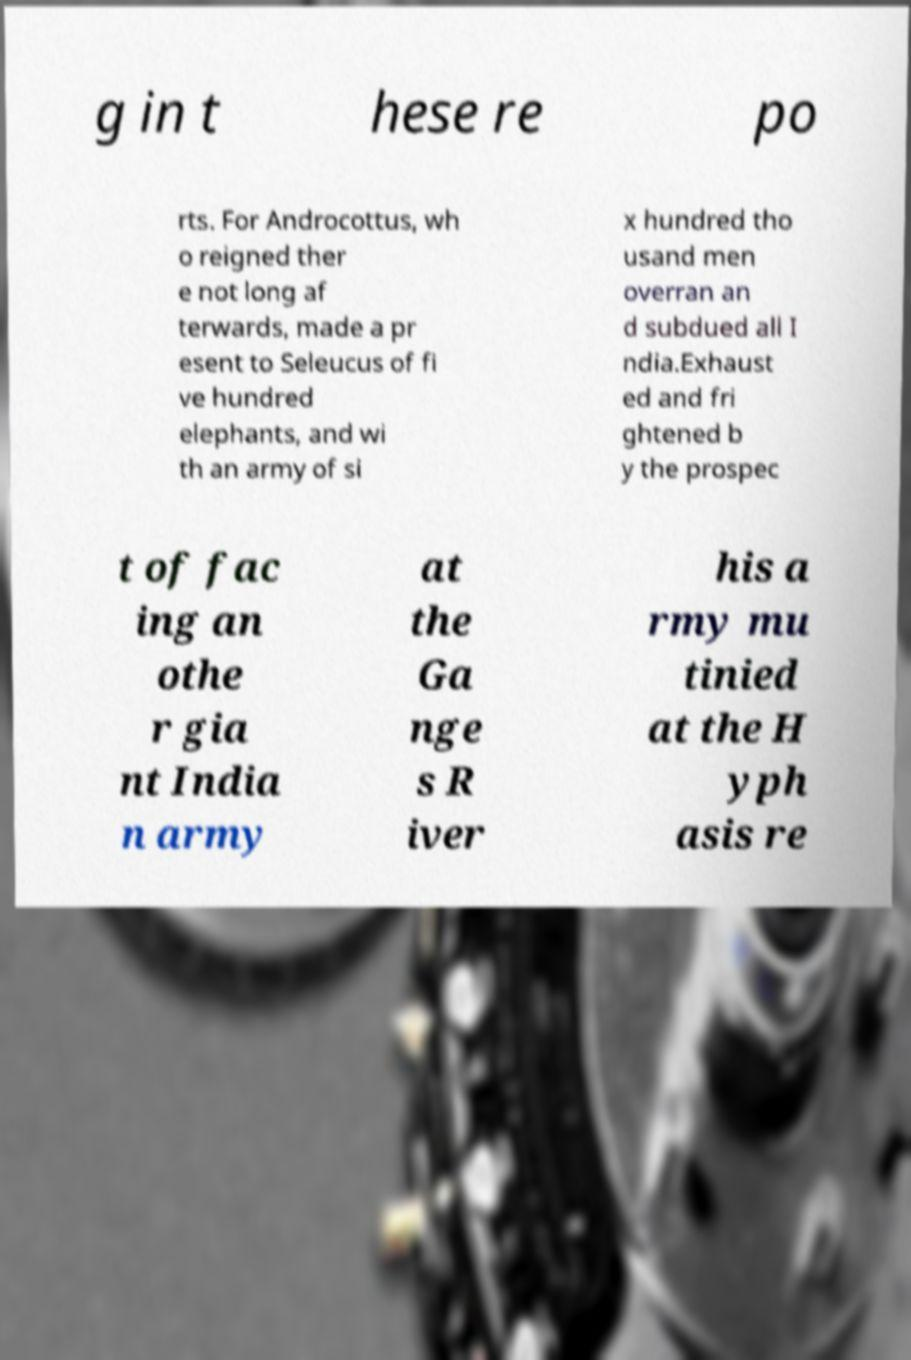Can you accurately transcribe the text from the provided image for me? g in t hese re po rts. For Androcottus, wh o reigned ther e not long af terwards, made a pr esent to Seleucus of fi ve hundred elephants, and wi th an army of si x hundred tho usand men overran an d subdued all I ndia.Exhaust ed and fri ghtened b y the prospec t of fac ing an othe r gia nt India n army at the Ga nge s R iver his a rmy mu tinied at the H yph asis re 